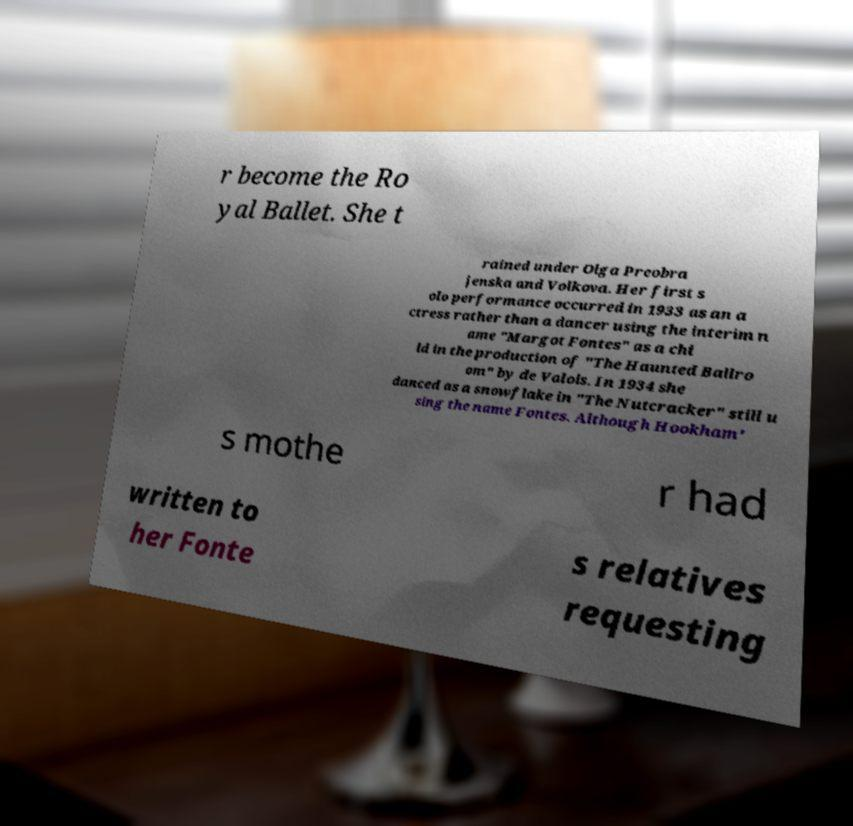I need the written content from this picture converted into text. Can you do that? r become the Ro yal Ballet. She t rained under Olga Preobra jenska and Volkova. Her first s olo performance occurred in 1933 as an a ctress rather than a dancer using the interim n ame "Margot Fontes" as a chi ld in the production of "The Haunted Ballro om" by de Valois. In 1934 she danced as a snowflake in "The Nutcracker" still u sing the name Fontes. Although Hookham' s mothe r had written to her Fonte s relatives requesting 